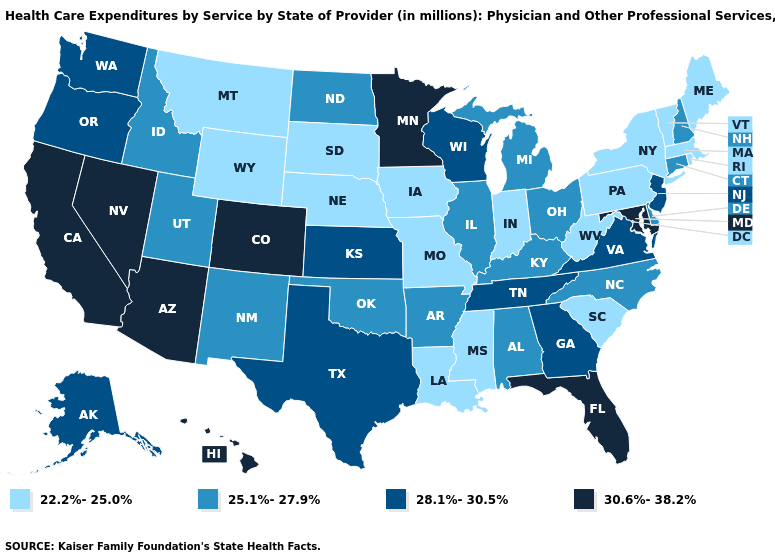Name the states that have a value in the range 22.2%-25.0%?
Concise answer only. Indiana, Iowa, Louisiana, Maine, Massachusetts, Mississippi, Missouri, Montana, Nebraska, New York, Pennsylvania, Rhode Island, South Carolina, South Dakota, Vermont, West Virginia, Wyoming. What is the value of New Mexico?
Concise answer only. 25.1%-27.9%. What is the value of Virginia?
Short answer required. 28.1%-30.5%. Among the states that border Washington , which have the lowest value?
Short answer required. Idaho. Name the states that have a value in the range 25.1%-27.9%?
Give a very brief answer. Alabama, Arkansas, Connecticut, Delaware, Idaho, Illinois, Kentucky, Michigan, New Hampshire, New Mexico, North Carolina, North Dakota, Ohio, Oklahoma, Utah. What is the highest value in the MidWest ?
Answer briefly. 30.6%-38.2%. Among the states that border Texas , which have the highest value?
Give a very brief answer. Arkansas, New Mexico, Oklahoma. What is the value of Idaho?
Short answer required. 25.1%-27.9%. Is the legend a continuous bar?
Concise answer only. No. Among the states that border Wisconsin , which have the lowest value?
Write a very short answer. Iowa. What is the value of Florida?
Keep it brief. 30.6%-38.2%. Does Arkansas have the same value as Illinois?
Quick response, please. Yes. What is the lowest value in the South?
Quick response, please. 22.2%-25.0%. What is the value of Ohio?
Quick response, please. 25.1%-27.9%. Does Idaho have the highest value in the West?
Write a very short answer. No. 